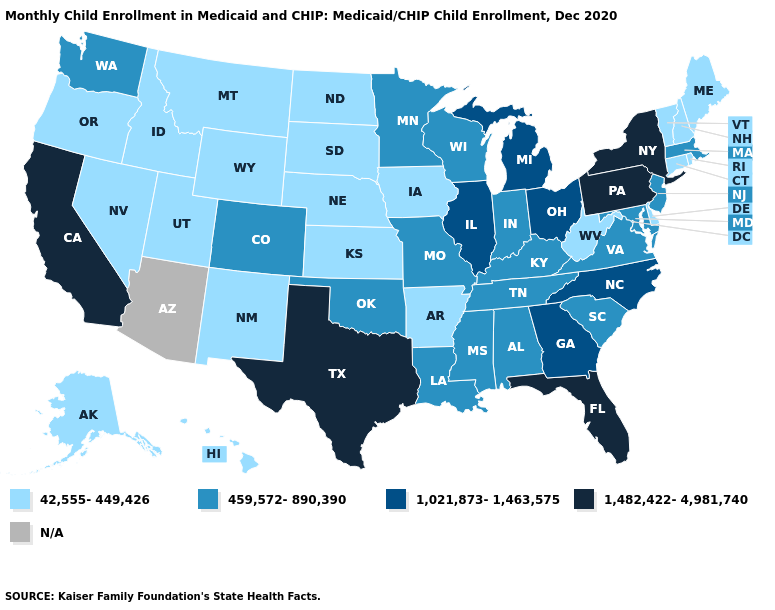What is the value of Massachusetts?
Concise answer only. 459,572-890,390. Name the states that have a value in the range 1,021,873-1,463,575?
Give a very brief answer. Georgia, Illinois, Michigan, North Carolina, Ohio. Name the states that have a value in the range 1,021,873-1,463,575?
Short answer required. Georgia, Illinois, Michigan, North Carolina, Ohio. Among the states that border Kansas , does Nebraska have the highest value?
Answer briefly. No. What is the lowest value in the USA?
Write a very short answer. 42,555-449,426. What is the value of California?
Short answer required. 1,482,422-4,981,740. What is the value of Oregon?
Write a very short answer. 42,555-449,426. Does Texas have the highest value in the South?
Quick response, please. Yes. Name the states that have a value in the range 459,572-890,390?
Concise answer only. Alabama, Colorado, Indiana, Kentucky, Louisiana, Maryland, Massachusetts, Minnesota, Mississippi, Missouri, New Jersey, Oklahoma, South Carolina, Tennessee, Virginia, Washington, Wisconsin. Name the states that have a value in the range 459,572-890,390?
Short answer required. Alabama, Colorado, Indiana, Kentucky, Louisiana, Maryland, Massachusetts, Minnesota, Mississippi, Missouri, New Jersey, Oklahoma, South Carolina, Tennessee, Virginia, Washington, Wisconsin. Name the states that have a value in the range N/A?
Keep it brief. Arizona. Does the first symbol in the legend represent the smallest category?
Give a very brief answer. Yes. Which states have the lowest value in the South?
Keep it brief. Arkansas, Delaware, West Virginia. 